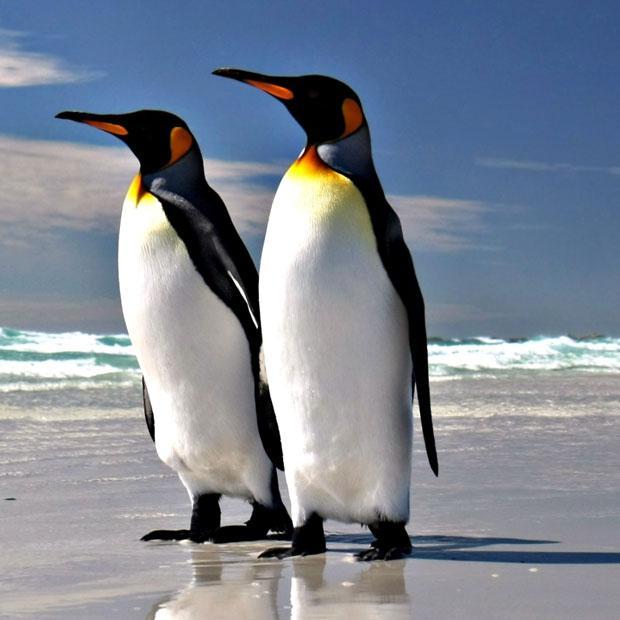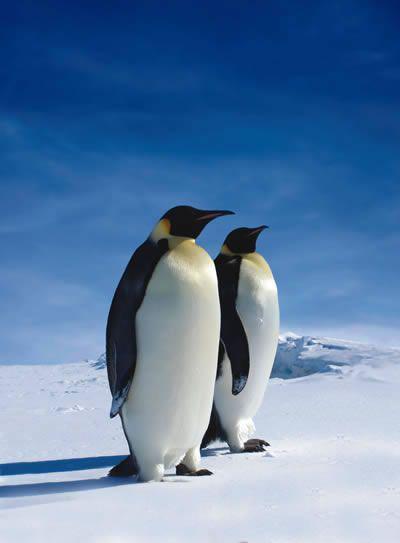The first image is the image on the left, the second image is the image on the right. Examine the images to the left and right. Is the description "There is at least one image containing only two penguins." accurate? Answer yes or no. Yes. The first image is the image on the left, the second image is the image on the right. Assess this claim about the two images: "There are two penguins standing together in the left image.". Correct or not? Answer yes or no. Yes. 